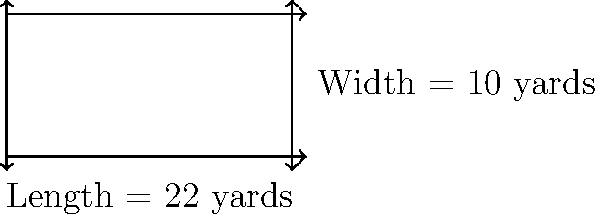In the sacred game of cricket, Bhayyuji Maharaj often emphasized the importance of precise measurements. A rectangular cricket pitch has a length of 22 yards and a width of 10 yards. What is the perimeter of this pitch in yards? Let's approach this step-by-step, keeping in mind Bhayyuji Maharaj's teachings on precision:

1) The formula for the perimeter of a rectangle is:
   $$ P = 2l + 2w $$
   where $P$ is the perimeter, $l$ is the length, and $w$ is the width.

2) We are given:
   Length ($l$) = 22 yards
   Width ($w$) = 10 yards

3) Let's substitute these values into our formula:
   $$ P = 2(22) + 2(10) $$

4) First, let's calculate the parts inside the parentheses:
   $$ P = 44 + 20 $$

5) Now, we can simply add these numbers:
   $$ P = 64 $$

Therefore, the perimeter of the cricket pitch is 64 yards.
Answer: 64 yards 